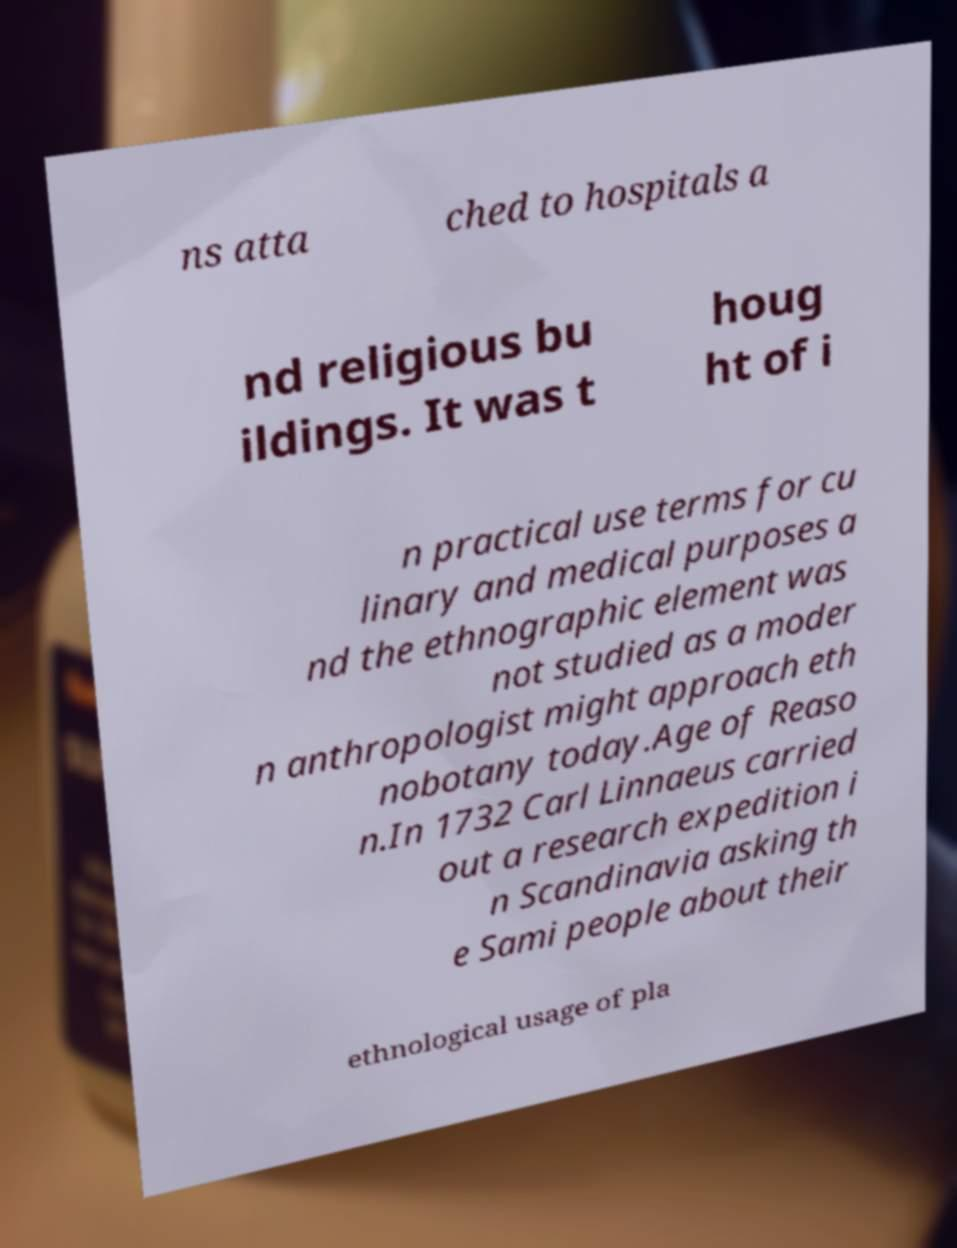Could you extract and type out the text from this image? ns atta ched to hospitals a nd religious bu ildings. It was t houg ht of i n practical use terms for cu linary and medical purposes a nd the ethnographic element was not studied as a moder n anthropologist might approach eth nobotany today.Age of Reaso n.In 1732 Carl Linnaeus carried out a research expedition i n Scandinavia asking th e Sami people about their ethnological usage of pla 